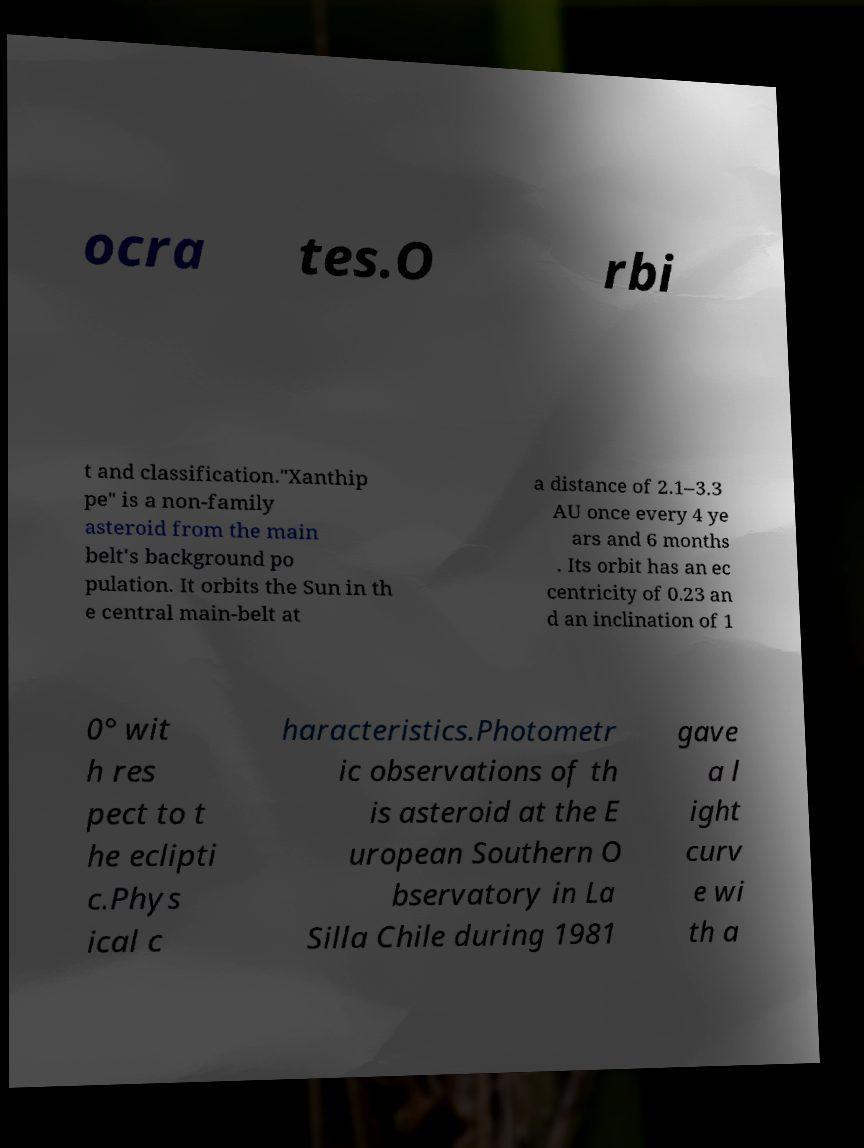Please read and relay the text visible in this image. What does it say? ocra tes.O rbi t and classification."Xanthip pe" is a non-family asteroid from the main belt's background po pulation. It orbits the Sun in th e central main-belt at a distance of 2.1–3.3 AU once every 4 ye ars and 6 months . Its orbit has an ec centricity of 0.23 an d an inclination of 1 0° wit h res pect to t he eclipti c.Phys ical c haracteristics.Photometr ic observations of th is asteroid at the E uropean Southern O bservatory in La Silla Chile during 1981 gave a l ight curv e wi th a 